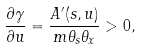<formula> <loc_0><loc_0><loc_500><loc_500>\frac { \partial \gamma } { \partial u } = \frac { A ^ { \prime } ( s , u ) } { m \theta _ { s } \theta _ { x } } > 0 ,</formula> 